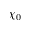<formula> <loc_0><loc_0><loc_500><loc_500>\chi _ { 0 }</formula> 